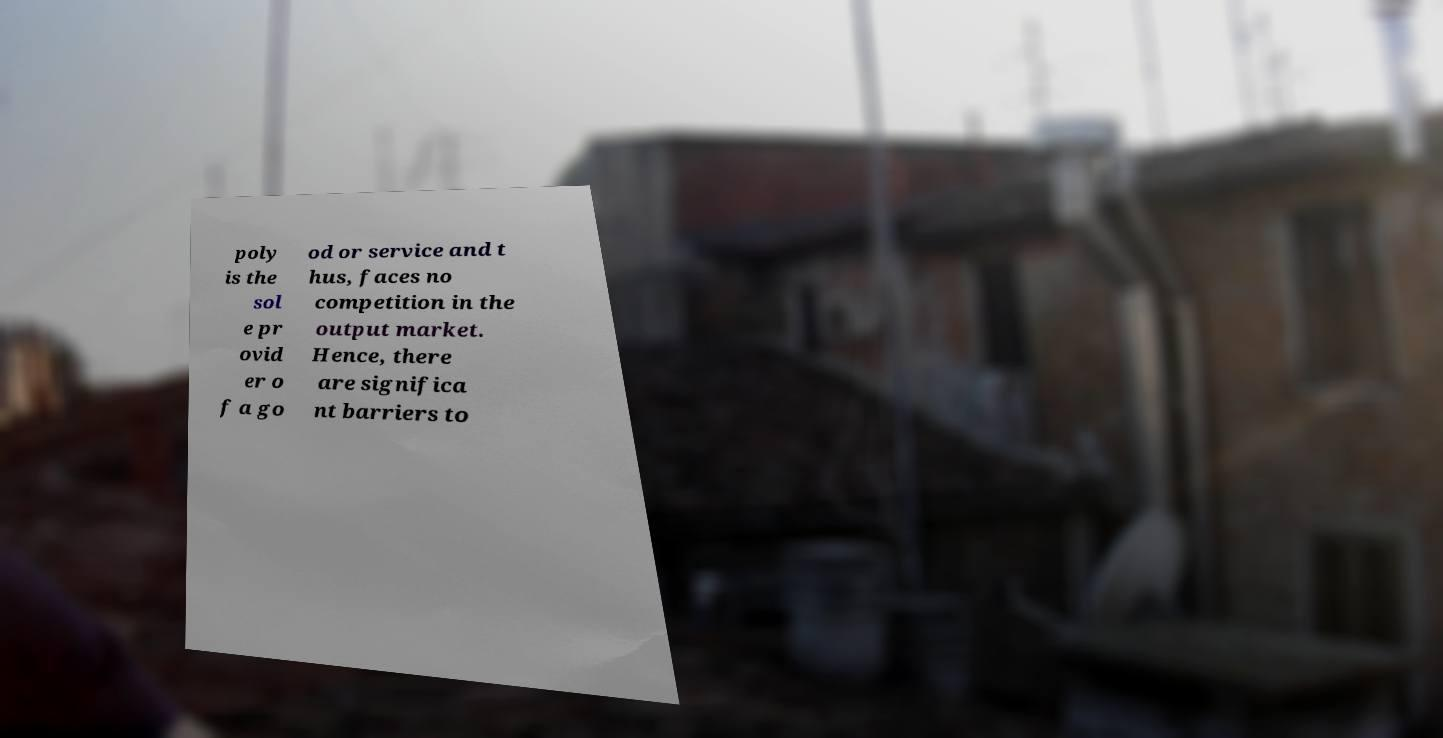Can you read and provide the text displayed in the image?This photo seems to have some interesting text. Can you extract and type it out for me? poly is the sol e pr ovid er o f a go od or service and t hus, faces no competition in the output market. Hence, there are significa nt barriers to 